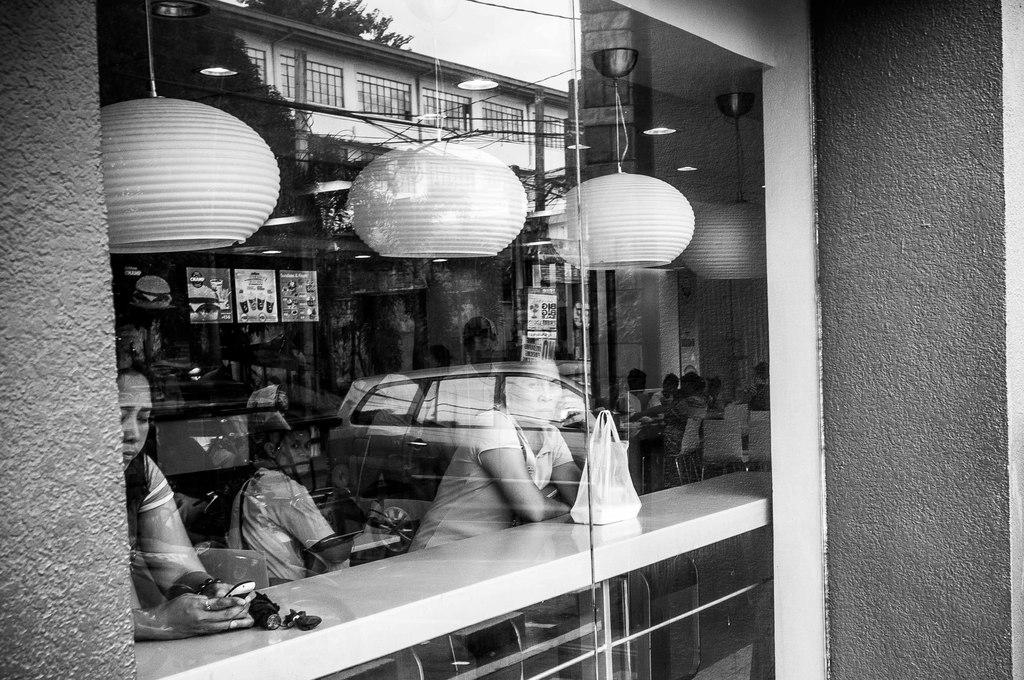What is the color scheme of the image? The image is black and white. What architectural feature can be seen in the image? There is a window in the image. What can be observed through the window? There are people visible inside the window. What is reflected on the glass of the window? The image of a vehicle is reflected on the glass of the window. How many birds are sitting on the beds in the image? There are no birds or beds present in the image. 